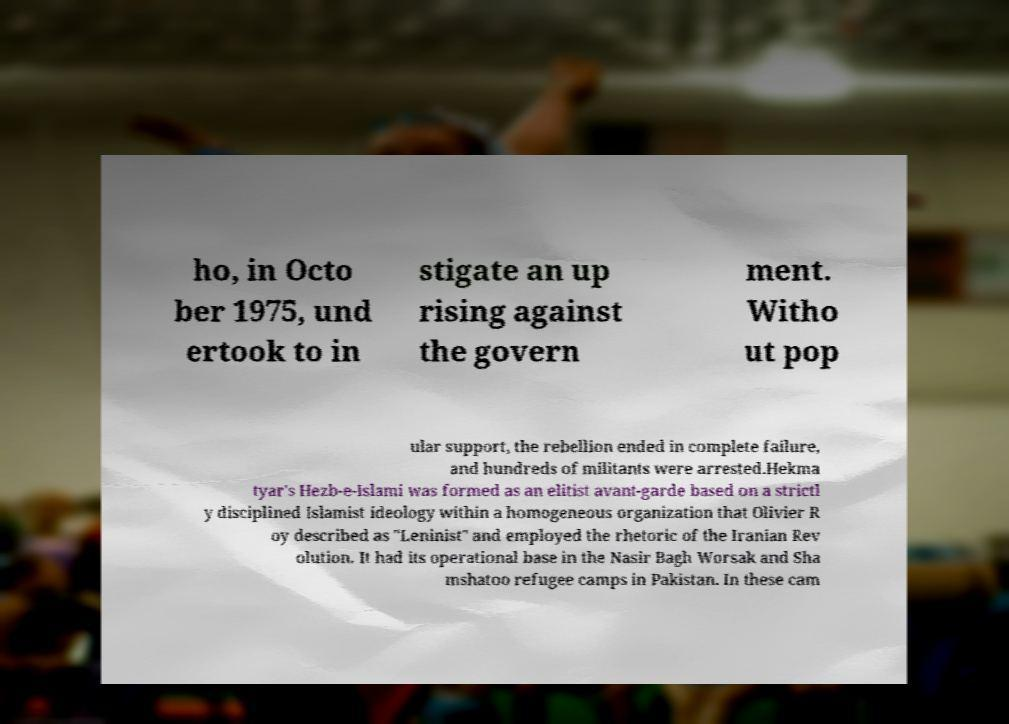There's text embedded in this image that I need extracted. Can you transcribe it verbatim? ho, in Octo ber 1975, und ertook to in stigate an up rising against the govern ment. Witho ut pop ular support, the rebellion ended in complete failure, and hundreds of militants were arrested.Hekma tyar's Hezb-e-Islami was formed as an elitist avant-garde based on a strictl y disciplined Islamist ideology within a homogeneous organization that Olivier R oy described as "Leninist" and employed the rhetoric of the Iranian Rev olution. It had its operational base in the Nasir Bagh Worsak and Sha mshatoo refugee camps in Pakistan. In these cam 